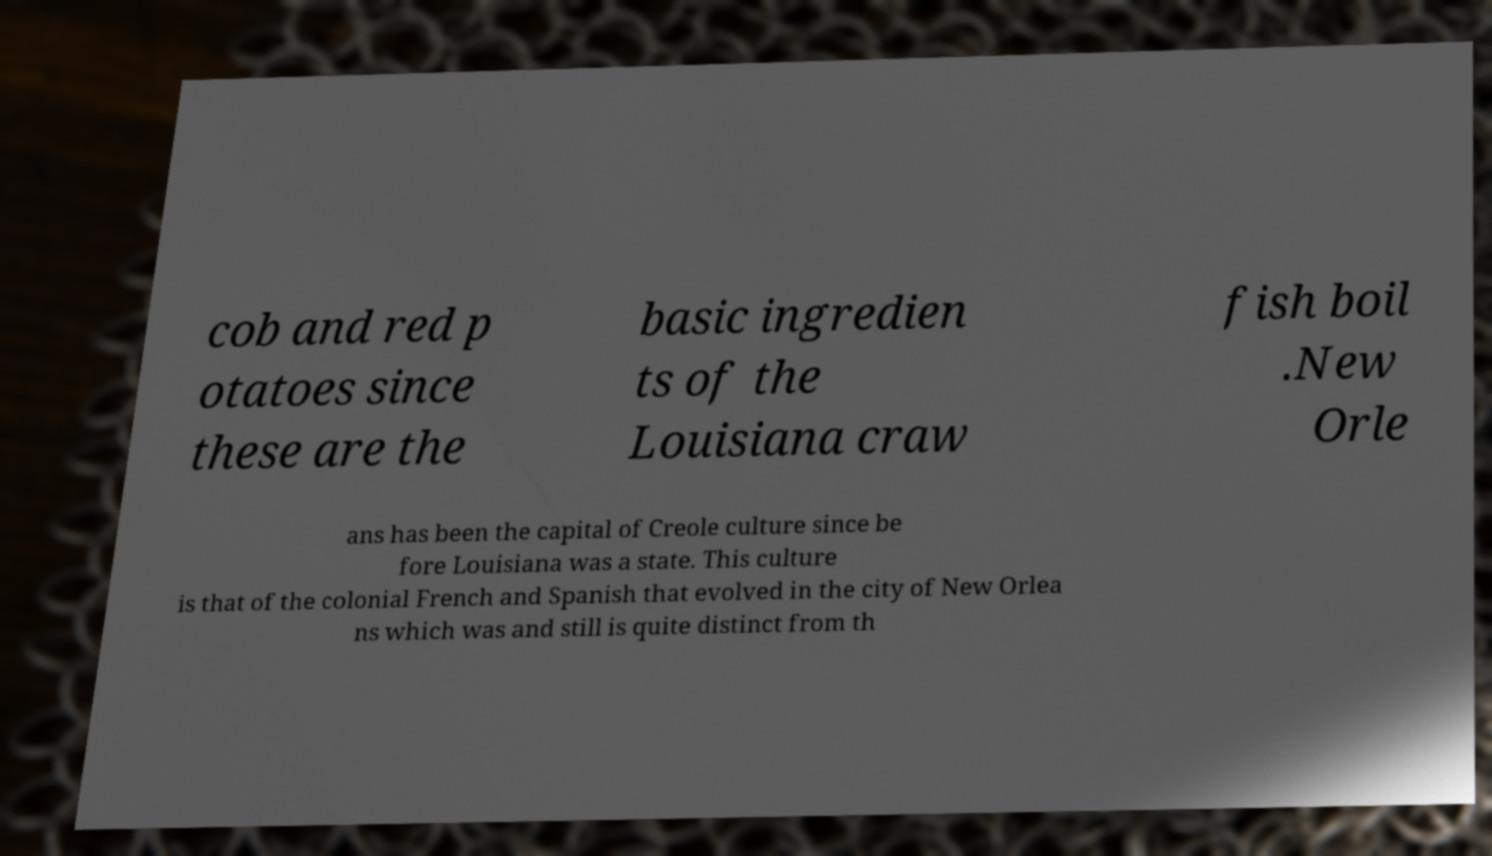Could you extract and type out the text from this image? cob and red p otatoes since these are the basic ingredien ts of the Louisiana craw fish boil .New Orle ans has been the capital of Creole culture since be fore Louisiana was a state. This culture is that of the colonial French and Spanish that evolved in the city of New Orlea ns which was and still is quite distinct from th 